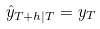<formula> <loc_0><loc_0><loc_500><loc_500>\hat { y } _ { T + h | T } = y _ { T }</formula> 